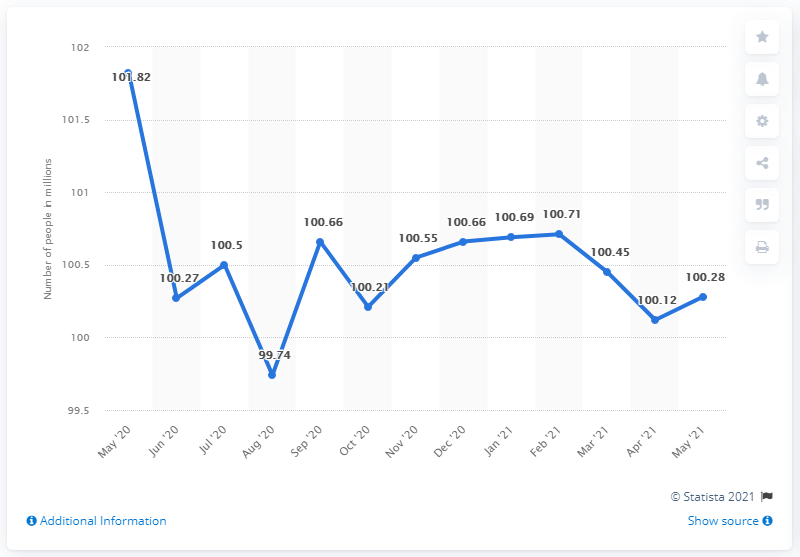Specify some key components in this picture. In May 2021, the number of people in the inactive labor force was 100.28 million. The leftmost value in a graph is often considered the peak value. The average of the two rightmost values is less than the value from March '21, indicating that the trend is not in favor of the Mar '21 value. 